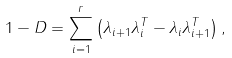Convert formula to latex. <formula><loc_0><loc_0><loc_500><loc_500>1 - D = \sum _ { i = 1 } ^ { r } \left ( \lambda _ { i + 1 } \lambda _ { i } ^ { T } - \lambda _ { i } \lambda _ { i + 1 } ^ { T } \right ) ,</formula> 